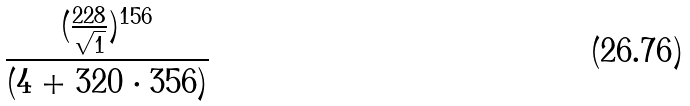<formula> <loc_0><loc_0><loc_500><loc_500>\frac { ( \frac { 2 2 8 } { \sqrt { 1 } } ) ^ { 1 5 6 } } { ( 4 + 3 2 0 \cdot 3 5 6 ) }</formula> 